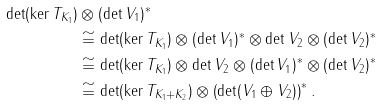<formula> <loc_0><loc_0><loc_500><loc_500>\det ( \ker T _ { K _ { 1 } } ) & \otimes ( \det V _ { 1 } ) ^ { * } \\ & \cong \det ( \ker T _ { K _ { 1 } } ) \otimes ( \det V _ { 1 } ) ^ { * } \otimes \det V _ { 2 } \otimes ( \det V _ { 2 } ) ^ { * } \\ & \cong \det ( \ker T _ { K _ { 1 } } ) \otimes \det V _ { 2 } \otimes ( \det V _ { 1 } ) ^ { * } \otimes ( \det V _ { 2 } ) ^ { * } \\ & \cong \det ( \ker T _ { K _ { 1 } + K _ { 2 } } ) \otimes \left ( \det ( V _ { 1 } \oplus V _ { 2 } ) \right ) ^ { * } .</formula> 